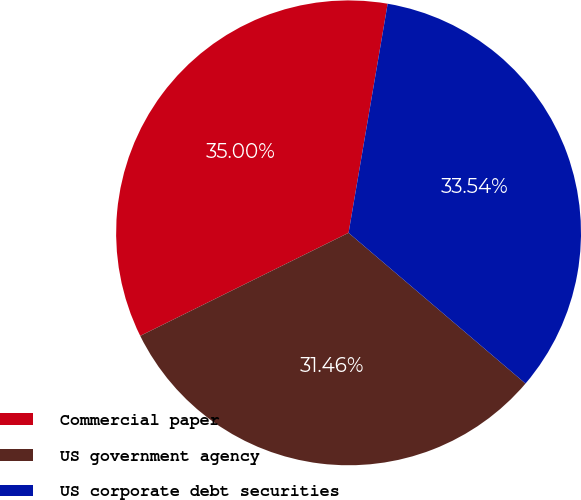Convert chart to OTSL. <chart><loc_0><loc_0><loc_500><loc_500><pie_chart><fcel>Commercial paper<fcel>US government agency<fcel>US corporate debt securities<nl><fcel>35.0%<fcel>31.46%<fcel>33.54%<nl></chart> 